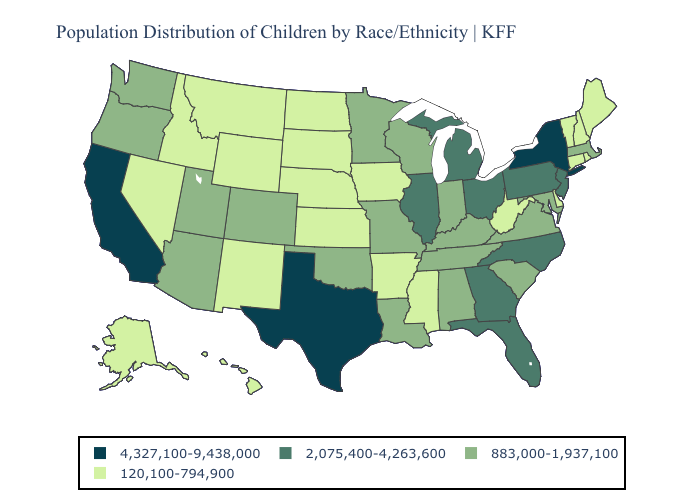What is the lowest value in the South?
Answer briefly. 120,100-794,900. Name the states that have a value in the range 4,327,100-9,438,000?
Answer briefly. California, New York, Texas. Which states have the highest value in the USA?
Concise answer only. California, New York, Texas. Does Maryland have the lowest value in the USA?
Be succinct. No. Among the states that border Washington , does Oregon have the lowest value?
Keep it brief. No. What is the value of North Dakota?
Be succinct. 120,100-794,900. Does Wisconsin have the highest value in the USA?
Short answer required. No. What is the lowest value in the MidWest?
Short answer required. 120,100-794,900. What is the value of Mississippi?
Give a very brief answer. 120,100-794,900. Among the states that border Vermont , which have the highest value?
Answer briefly. New York. Does New Jersey have the lowest value in the Northeast?
Concise answer only. No. What is the value of Mississippi?
Give a very brief answer. 120,100-794,900. What is the highest value in states that border New Hampshire?
Answer briefly. 883,000-1,937,100. Which states have the lowest value in the MidWest?
Keep it brief. Iowa, Kansas, Nebraska, North Dakota, South Dakota. Among the states that border Vermont , does Massachusetts have the lowest value?
Write a very short answer. No. 